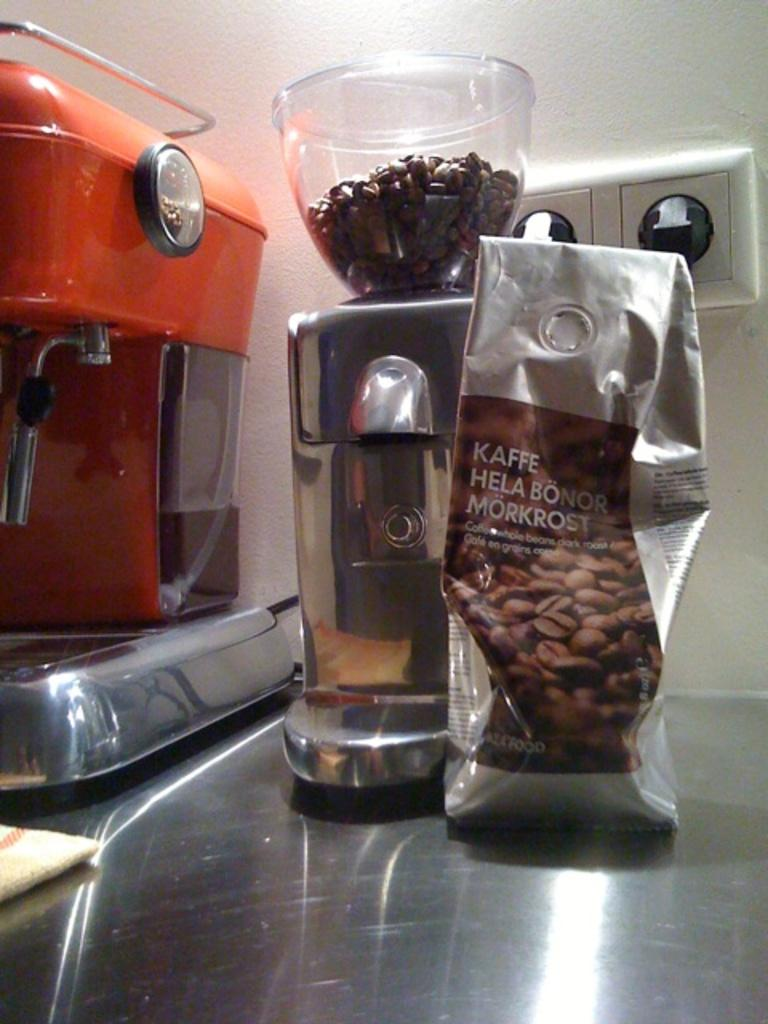<image>
Offer a succinct explanation of the picture presented. A packet of Kaffe Hela Bonor Morkrost is being used to make coffee. 